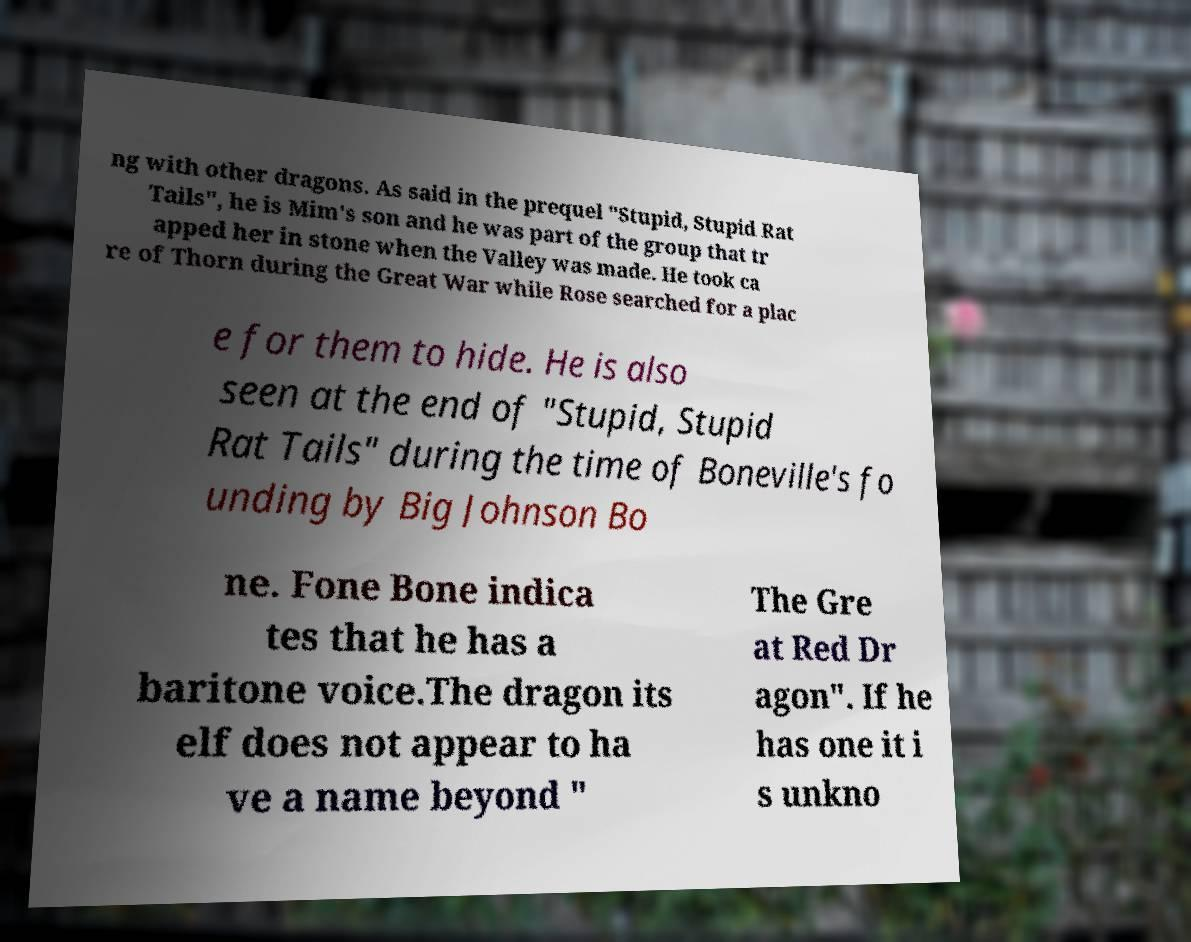Can you read and provide the text displayed in the image?This photo seems to have some interesting text. Can you extract and type it out for me? ng with other dragons. As said in the prequel "Stupid, Stupid Rat Tails", he is Mim's son and he was part of the group that tr apped her in stone when the Valley was made. He took ca re of Thorn during the Great War while Rose searched for a plac e for them to hide. He is also seen at the end of "Stupid, Stupid Rat Tails" during the time of Boneville's fo unding by Big Johnson Bo ne. Fone Bone indica tes that he has a baritone voice.The dragon its elf does not appear to ha ve a name beyond " The Gre at Red Dr agon". If he has one it i s unkno 